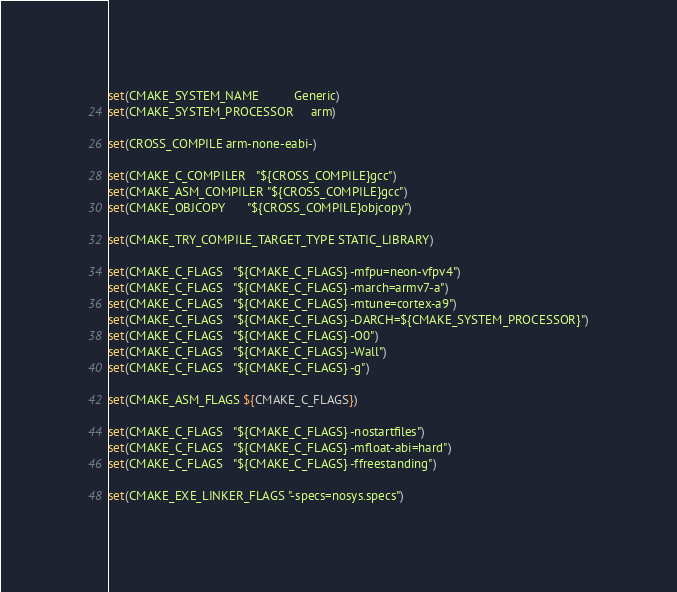<code> <loc_0><loc_0><loc_500><loc_500><_CMake_>set(CMAKE_SYSTEM_NAME          Generic)
set(CMAKE_SYSTEM_PROCESSOR     arm)

set(CROSS_COMPILE arm-none-eabi-)

set(CMAKE_C_COMPILER   "${CROSS_COMPILE}gcc")
set(CMAKE_ASM_COMPILER "${CROSS_COMPILE}gcc")
set(CMAKE_OBJCOPY      "${CROSS_COMPILE}objcopy")

set(CMAKE_TRY_COMPILE_TARGET_TYPE STATIC_LIBRARY)

set(CMAKE_C_FLAGS   "${CMAKE_C_FLAGS} -mfpu=neon-vfpv4")
set(CMAKE_C_FLAGS   "${CMAKE_C_FLAGS} -march=armv7-a")
set(CMAKE_C_FLAGS   "${CMAKE_C_FLAGS} -mtune=cortex-a9")
set(CMAKE_C_FLAGS   "${CMAKE_C_FLAGS} -DARCH=${CMAKE_SYSTEM_PROCESSOR}")
set(CMAKE_C_FLAGS   "${CMAKE_C_FLAGS} -O0")
set(CMAKE_C_FLAGS   "${CMAKE_C_FLAGS} -Wall")
set(CMAKE_C_FLAGS   "${CMAKE_C_FLAGS} -g")

set(CMAKE_ASM_FLAGS ${CMAKE_C_FLAGS})

set(CMAKE_C_FLAGS   "${CMAKE_C_FLAGS} -nostartfiles")
set(CMAKE_C_FLAGS   "${CMAKE_C_FLAGS} -mfloat-abi=hard")
set(CMAKE_C_FLAGS   "${CMAKE_C_FLAGS} -ffreestanding")

set(CMAKE_EXE_LINKER_FLAGS "-specs=nosys.specs")
</code> 